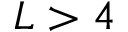Convert formula to latex. <formula><loc_0><loc_0><loc_500><loc_500>L > 4</formula> 